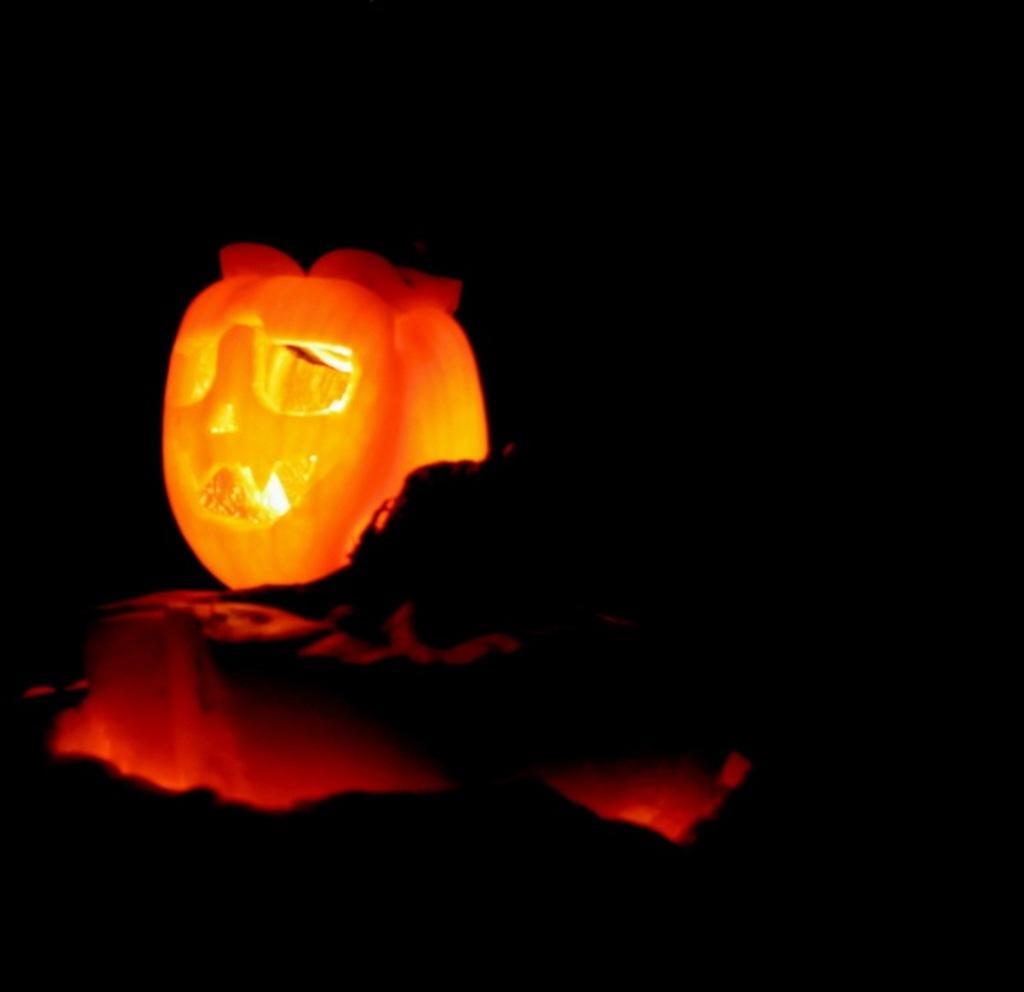Please provide a concise description of this image. In this image we can see a halloween pumpkin. 